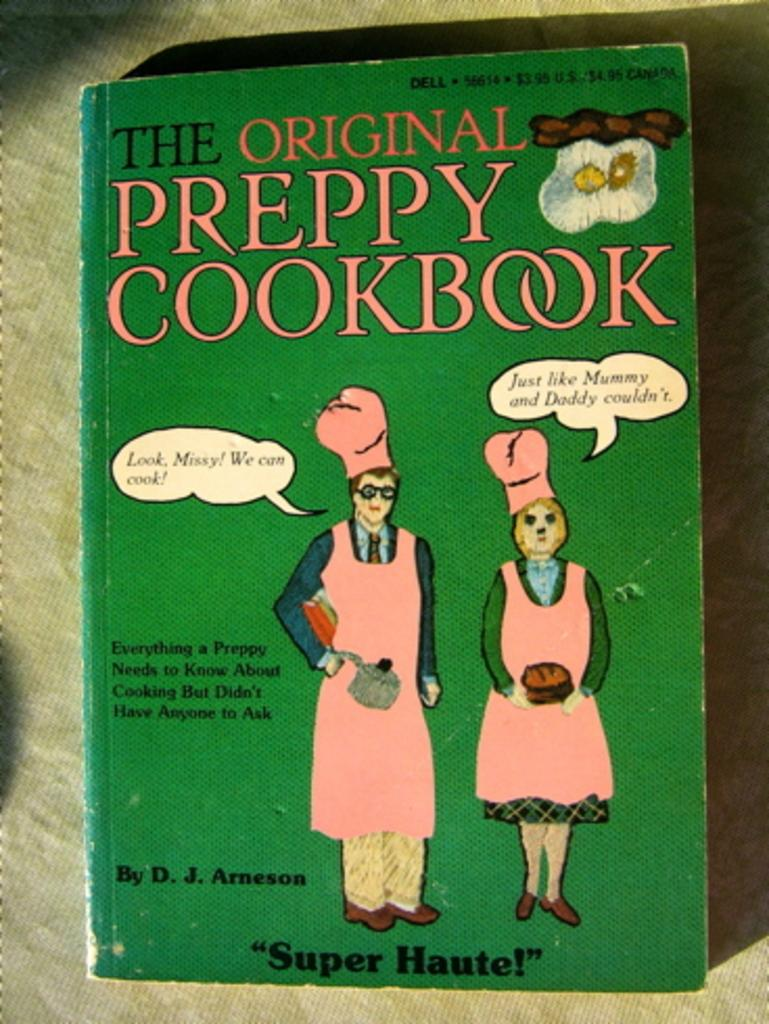<image>
Summarize the visual content of the image. An old green cookbook called The Original Preppy Cookbook. 